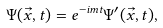<formula> <loc_0><loc_0><loc_500><loc_500>\Psi ( \vec { x } , t ) = e ^ { - i m t } \Psi ^ { \prime } ( \vec { x } , t ) ,</formula> 